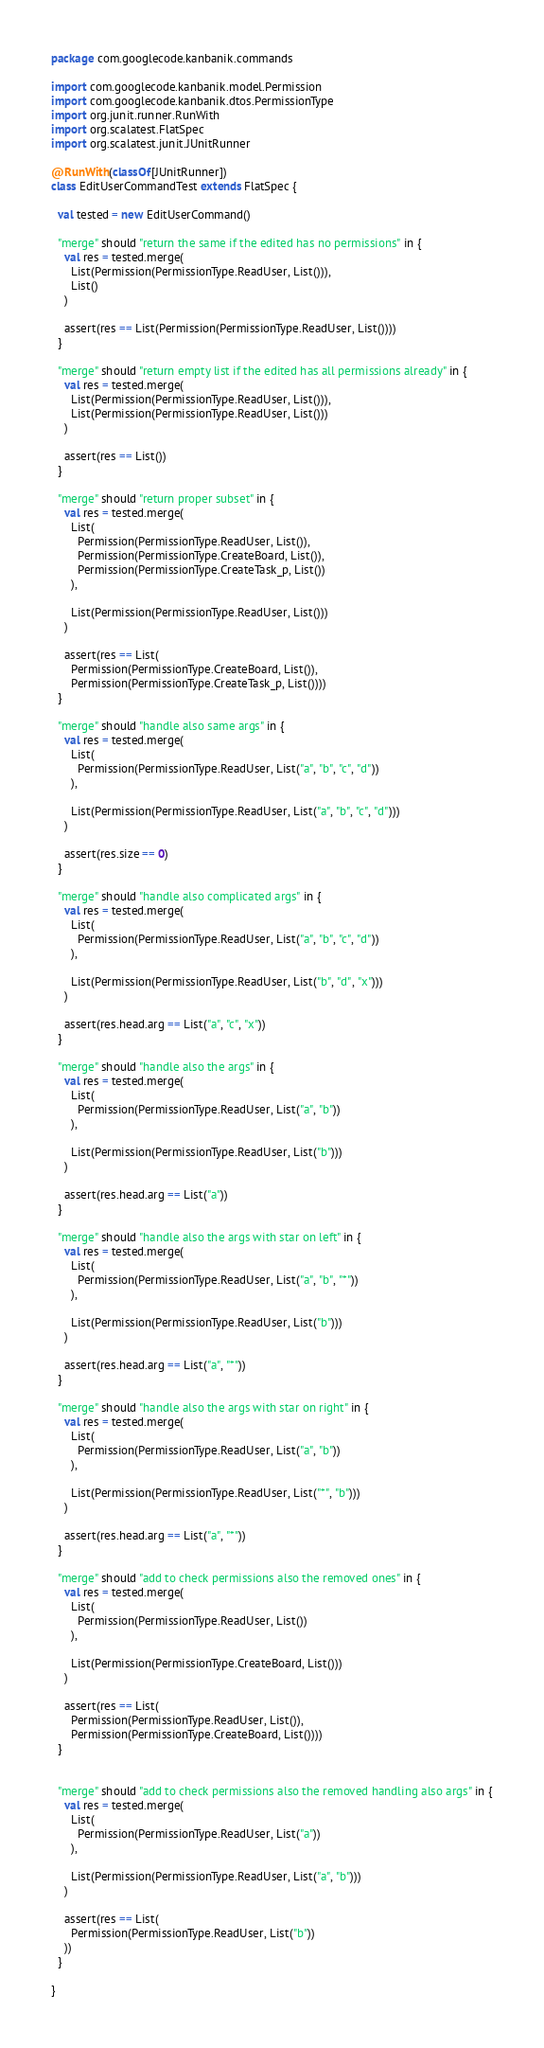<code> <loc_0><loc_0><loc_500><loc_500><_Scala_>package com.googlecode.kanbanik.commands

import com.googlecode.kanbanik.model.Permission
import com.googlecode.kanbanik.dtos.PermissionType
import org.junit.runner.RunWith
import org.scalatest.FlatSpec
import org.scalatest.junit.JUnitRunner

@RunWith(classOf[JUnitRunner])
class EditUserCommandTest extends FlatSpec {

  val tested = new EditUserCommand()

  "merge" should "return the same if the edited has no permissions" in {
    val res = tested.merge(
      List(Permission(PermissionType.ReadUser, List())),
      List()
    )

    assert(res == List(Permission(PermissionType.ReadUser, List())))
  }

  "merge" should "return empty list if the edited has all permissions already" in {
    val res = tested.merge(
      List(Permission(PermissionType.ReadUser, List())),
      List(Permission(PermissionType.ReadUser, List()))
    )

    assert(res == List())
  }

  "merge" should "return proper subset" in {
    val res = tested.merge(
      List(
        Permission(PermissionType.ReadUser, List()),
        Permission(PermissionType.CreateBoard, List()),
        Permission(PermissionType.CreateTask_p, List())
      ),

      List(Permission(PermissionType.ReadUser, List()))
    )

    assert(res == List(
      Permission(PermissionType.CreateBoard, List()),
      Permission(PermissionType.CreateTask_p, List())))
  }

  "merge" should "handle also same args" in {
    val res = tested.merge(
      List(
        Permission(PermissionType.ReadUser, List("a", "b", "c", "d"))
      ),

      List(Permission(PermissionType.ReadUser, List("a", "b", "c", "d")))
    )

    assert(res.size == 0)
  }

  "merge" should "handle also complicated args" in {
    val res = tested.merge(
      List(
        Permission(PermissionType.ReadUser, List("a", "b", "c", "d"))
      ),

      List(Permission(PermissionType.ReadUser, List("b", "d", "x")))
    )

    assert(res.head.arg == List("a", "c", "x"))
  }

  "merge" should "handle also the args" in {
    val res = tested.merge(
      List(
        Permission(PermissionType.ReadUser, List("a", "b"))
      ),

      List(Permission(PermissionType.ReadUser, List("b")))
    )

    assert(res.head.arg == List("a"))
  }

  "merge" should "handle also the args with star on left" in {
    val res = tested.merge(
      List(
        Permission(PermissionType.ReadUser, List("a", "b", "*"))
      ),

      List(Permission(PermissionType.ReadUser, List("b")))
    )

    assert(res.head.arg == List("a", "*"))
  }

  "merge" should "handle also the args with star on right" in {
    val res = tested.merge(
      List(
        Permission(PermissionType.ReadUser, List("a", "b"))
      ),

      List(Permission(PermissionType.ReadUser, List("*", "b")))
    )

    assert(res.head.arg == List("a", "*"))
  }

  "merge" should "add to check permissions also the removed ones" in {
    val res = tested.merge(
      List(
        Permission(PermissionType.ReadUser, List())
      ),

      List(Permission(PermissionType.CreateBoard, List()))
    )

    assert(res == List(
      Permission(PermissionType.ReadUser, List()),
      Permission(PermissionType.CreateBoard, List())))
  }


  "merge" should "add to check permissions also the removed handling also args" in {
    val res = tested.merge(
      List(
        Permission(PermissionType.ReadUser, List("a"))
      ),

      List(Permission(PermissionType.ReadUser, List("a", "b")))
    )

    assert(res == List(
      Permission(PermissionType.ReadUser, List("b"))
    ))
  }

}
</code> 